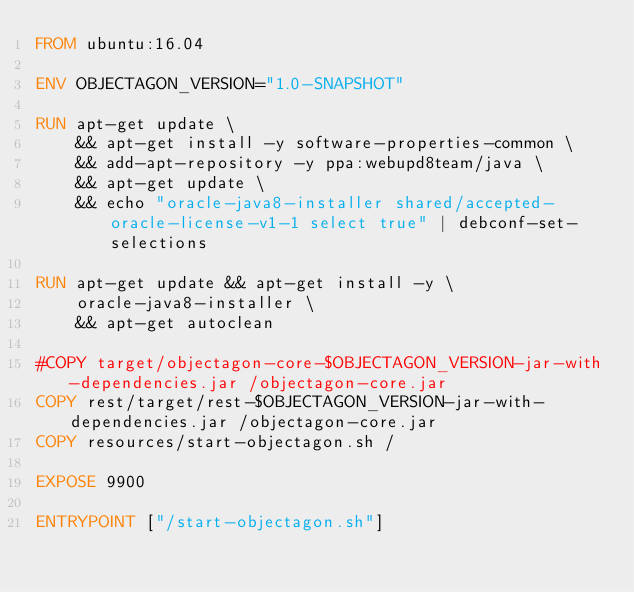<code> <loc_0><loc_0><loc_500><loc_500><_Dockerfile_>FROM ubuntu:16.04

ENV OBJECTAGON_VERSION="1.0-SNAPSHOT"

RUN apt-get update \
    && apt-get install -y software-properties-common \
    && add-apt-repository -y ppa:webupd8team/java \
    && apt-get update \
    && echo "oracle-java8-installer shared/accepted-oracle-license-v1-1 select true" | debconf-set-selections

RUN apt-get update && apt-get install -y \
    oracle-java8-installer \
    && apt-get autoclean

#COPY target/objectagon-core-$OBJECTAGON_VERSION-jar-with-dependencies.jar /objectagon-core.jar
COPY rest/target/rest-$OBJECTAGON_VERSION-jar-with-dependencies.jar /objectagon-core.jar
COPY resources/start-objectagon.sh /

EXPOSE 9900

ENTRYPOINT ["/start-objectagon.sh"]




</code> 